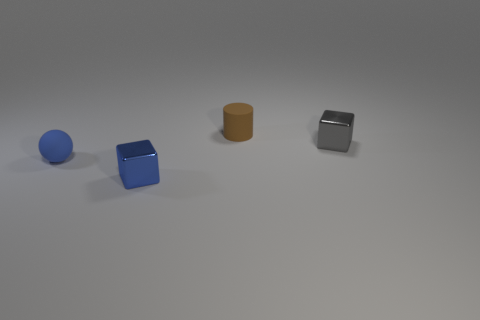Add 4 tiny rubber cylinders. How many objects exist? 8 Subtract all cylinders. How many objects are left? 3 Subtract 1 balls. How many balls are left? 0 Add 4 small blue rubber spheres. How many small blue rubber spheres are left? 5 Add 3 big purple matte balls. How many big purple matte balls exist? 3 Subtract all blue cubes. How many cubes are left? 1 Subtract 1 blue balls. How many objects are left? 3 Subtract all purple blocks. Subtract all cyan cylinders. How many blocks are left? 2 Subtract all purple blocks. How many brown spheres are left? 0 Subtract all small blue rubber objects. Subtract all gray rubber cylinders. How many objects are left? 3 